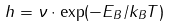<formula> <loc_0><loc_0><loc_500><loc_500>h = \nu \cdot \exp ( - E _ { B } / k _ { B } T )</formula> 